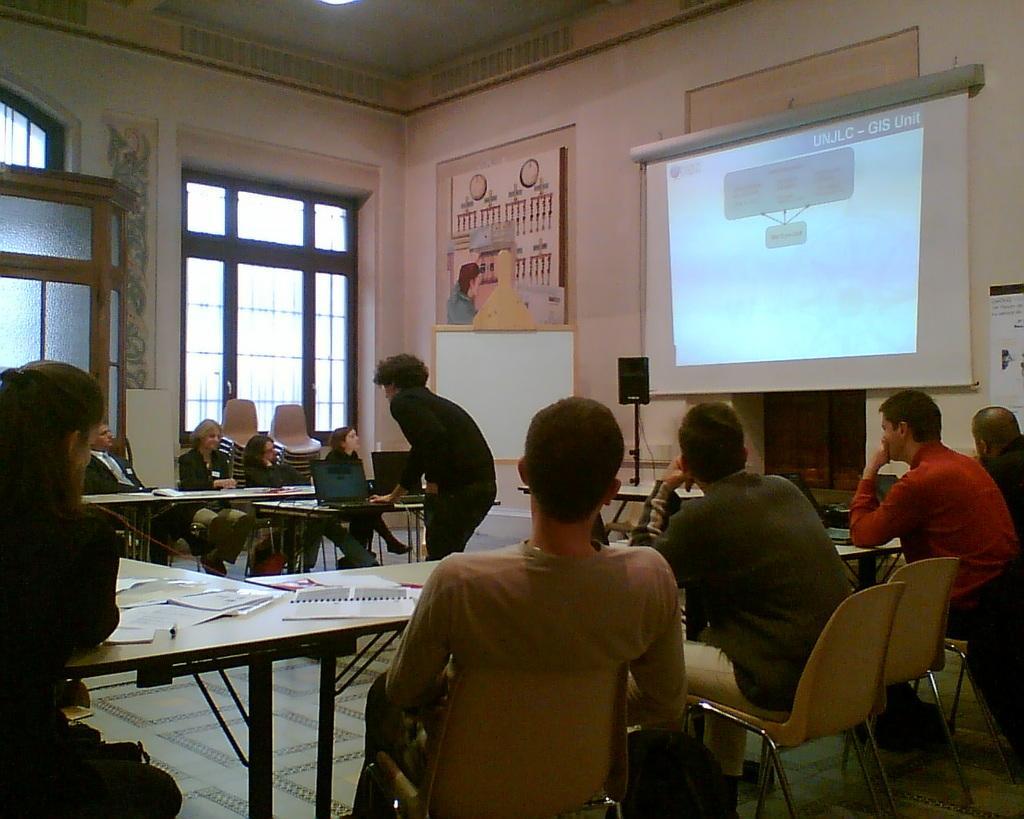Can you describe this image briefly? In the image we can see there are lot of people who are sitting on chair and in middle there is a person who is standing and on table there is a laptop. 